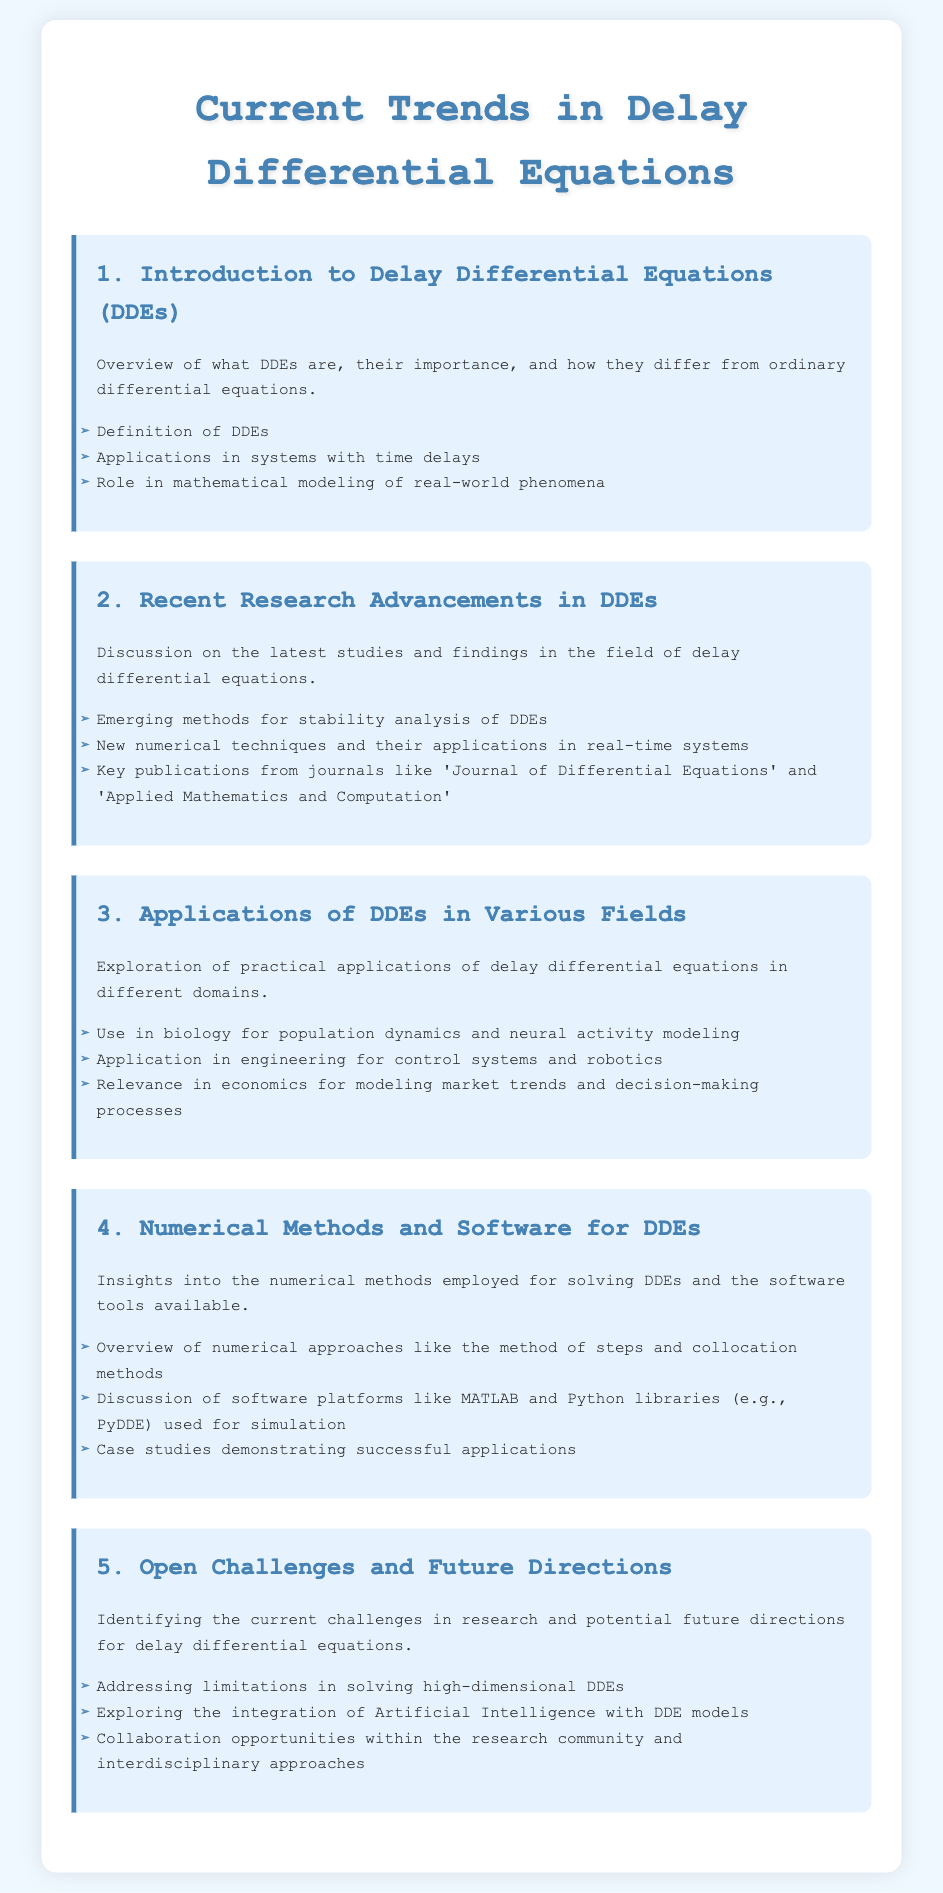What is the main focus of the document? The document focuses on current trends, applications, and research advancements in delay differential equations.
Answer: Current trends in Delay Differential Equations What section discusses emerging methods for stability analysis? This information can be found in the second agenda item titled "Recent Research Advancements in DDEs."
Answer: Recent Research Advancements in DDEs In which field are DDEs applied for modeling population dynamics? This application is mentioned in the third agenda item focusing on various fields.
Answer: Biology What numerical method is mentioned for solving DDEs? The document lists the method of steps among others in the fourth agenda item.
Answer: Method of steps What is one of the open challenges identified for DDEs? This is noted in the fifth agenda item discussing future directions.
Answer: Addressing limitations in solving high-dimensional DDEs Which software platform is referenced for simulation of DDEs? This information is provided in the fourth agenda item about software tools.
Answer: MATLAB What is the title of the first agenda item? The title is explicitly mentioned in the document's first section.
Answer: Introduction to Delay Differential Equations (DDEs) How many main sections are there in the document? The document lists a total of five agenda items, which corresponds to the main sections.
Answer: Five 